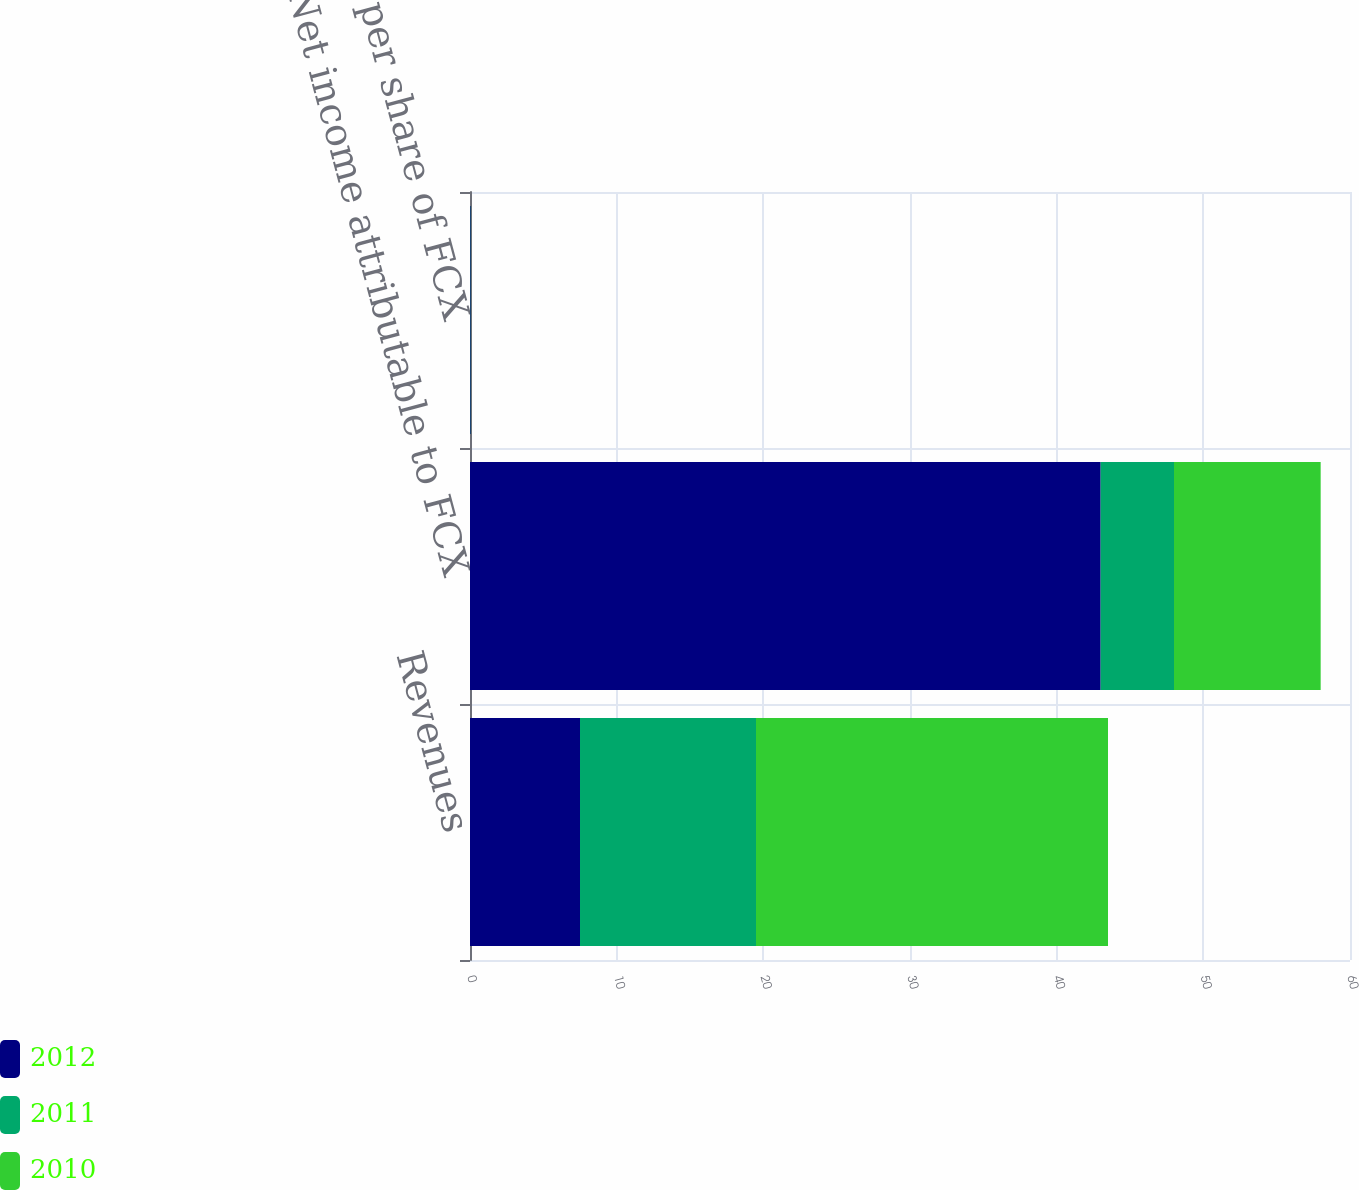Convert chart to OTSL. <chart><loc_0><loc_0><loc_500><loc_500><stacked_bar_chart><ecel><fcel>Revenues<fcel>Net income attributable to FCX<fcel>Net income per share of FCX<nl><fcel>2012<fcel>7.5<fcel>43<fcel>0.05<nl><fcel>2011<fcel>12<fcel>5<fcel>0.01<nl><fcel>2010<fcel>24<fcel>10<fcel>0.01<nl></chart> 